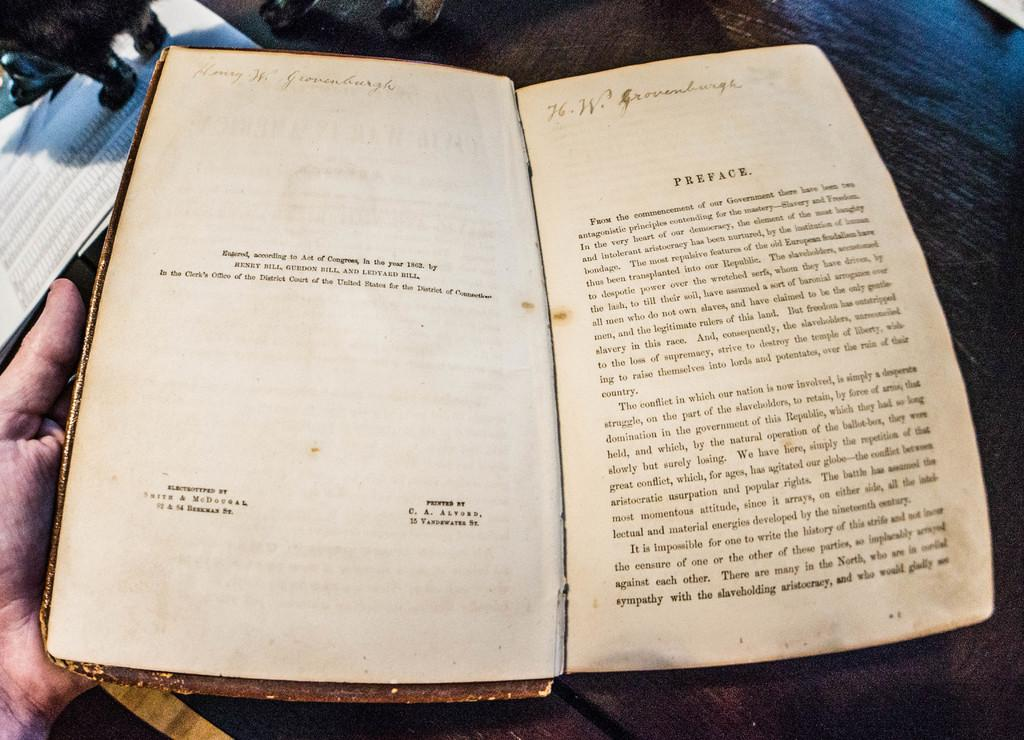Provide a one-sentence caption for the provided image. An old worn out book with the word "Preface" printed at the top of the page. 